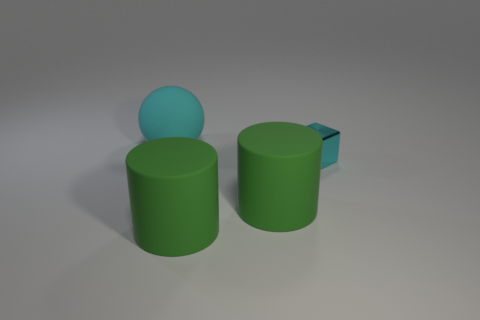Add 1 metal cubes. How many objects exist? 5 Subtract all spheres. How many objects are left? 3 Add 1 large cyan metallic objects. How many large cyan metallic objects exist? 1 Subtract 0 gray cylinders. How many objects are left? 4 Subtract all metallic cylinders. Subtract all spheres. How many objects are left? 3 Add 4 matte cylinders. How many matte cylinders are left? 6 